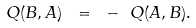<formula> <loc_0><loc_0><loc_500><loc_500>Q ( B , A ) \ = \ - \ Q ( A , B ) .</formula> 